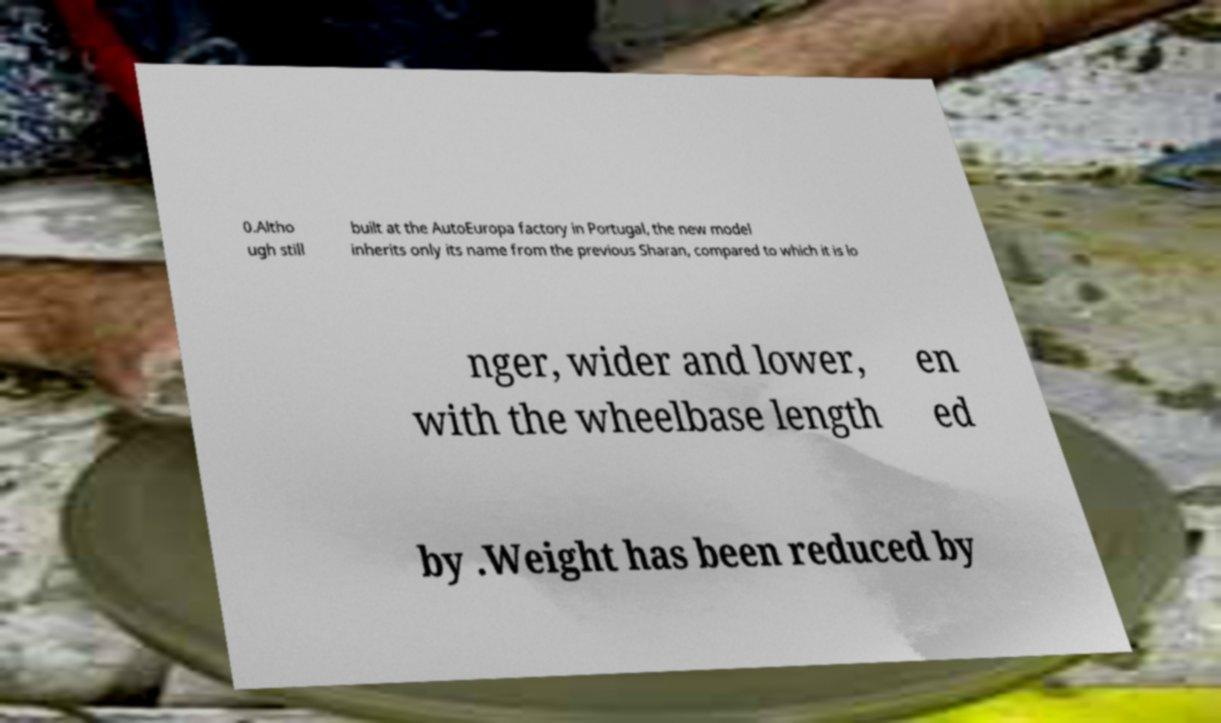Can you accurately transcribe the text from the provided image for me? 0.Altho ugh still built at the AutoEuropa factory in Portugal, the new model inherits only its name from the previous Sharan, compared to which it is lo nger, wider and lower, with the wheelbase length en ed by .Weight has been reduced by 